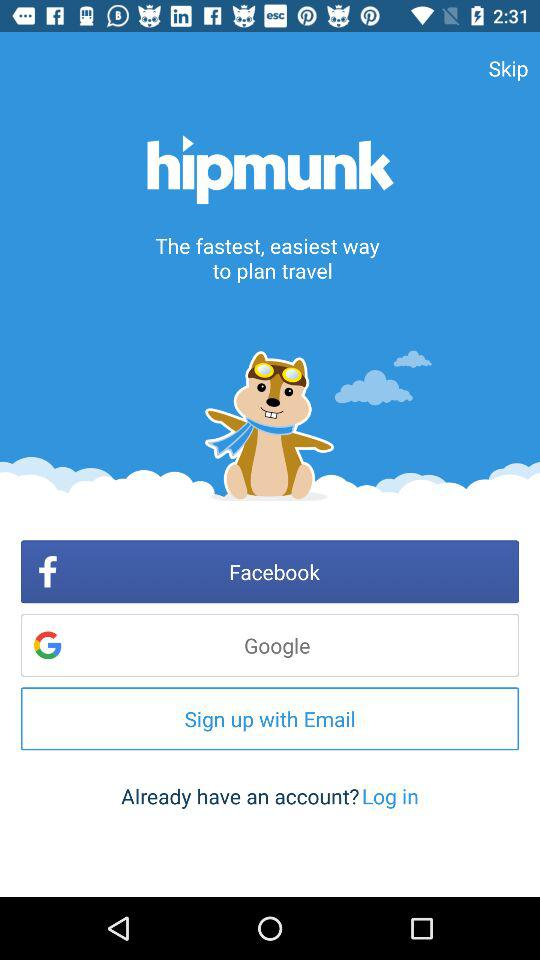What is the name of the application? The name of the application is "hipmunk". 